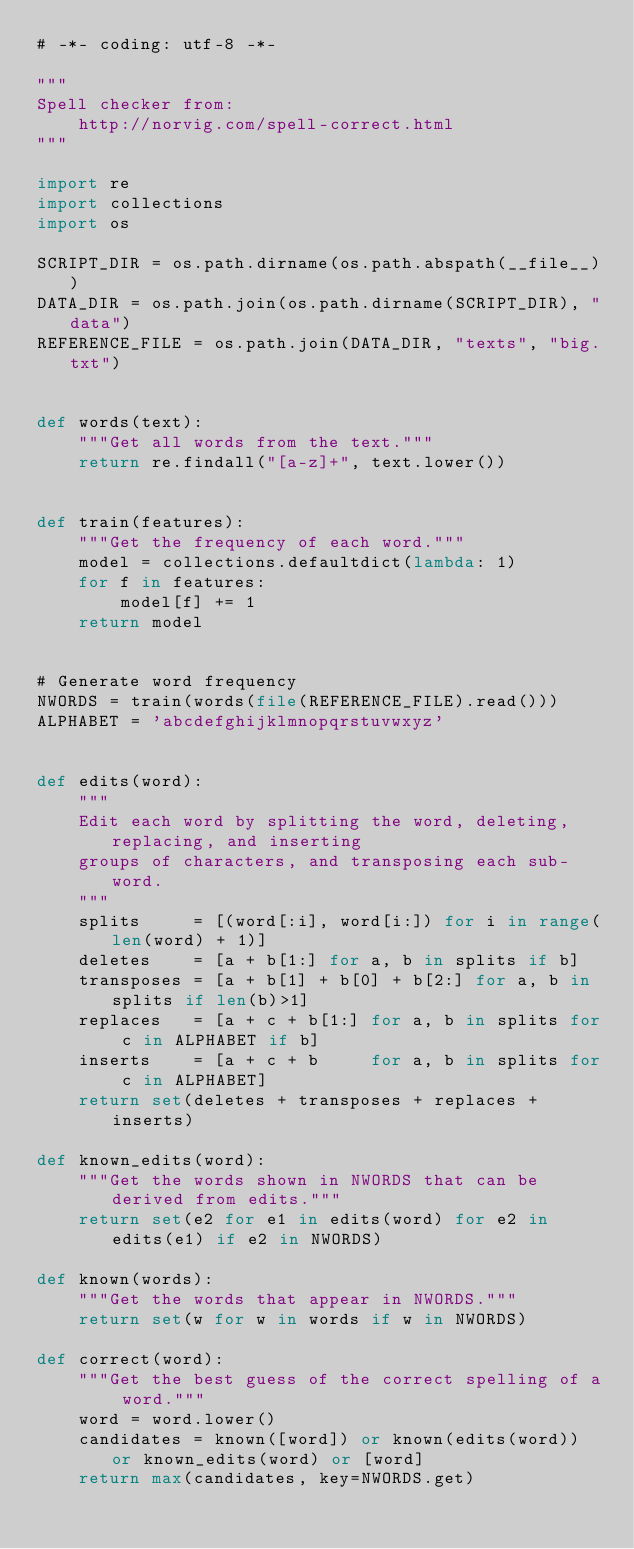<code> <loc_0><loc_0><loc_500><loc_500><_Python_># -*- coding: utf-8 -*-

"""
Spell checker from:
    http://norvig.com/spell-correct.html
"""

import re
import collections
import os

SCRIPT_DIR = os.path.dirname(os.path.abspath(__file__))
DATA_DIR = os.path.join(os.path.dirname(SCRIPT_DIR), "data")
REFERENCE_FILE = os.path.join(DATA_DIR, "texts", "big.txt")


def words(text):
    """Get all words from the text."""
    return re.findall("[a-z]+", text.lower())


def train(features):
    """Get the frequency of each word."""
    model = collections.defaultdict(lambda: 1)
    for f in features:
        model[f] += 1
    return model


# Generate word frequency
NWORDS = train(words(file(REFERENCE_FILE).read()))
ALPHABET = 'abcdefghijklmnopqrstuvwxyz'


def edits(word):
    """
    Edit each word by splitting the word, deleting, replacing, and inserting
    groups of characters, and transposing each sub-word.
    """
    splits     = [(word[:i], word[i:]) for i in range(len(word) + 1)]
    deletes    = [a + b[1:] for a, b in splits if b]
    transposes = [a + b[1] + b[0] + b[2:] for a, b in splits if len(b)>1]
    replaces   = [a + c + b[1:] for a, b in splits for c in ALPHABET if b]
    inserts    = [a + c + b     for a, b in splits for c in ALPHABET]
    return set(deletes + transposes + replaces + inserts)

def known_edits(word):
    """Get the words shown in NWORDS that can be derived from edits."""
    return set(e2 for e1 in edits(word) for e2 in edits(e1) if e2 in NWORDS)

def known(words):
    """Get the words that appear in NWORDS."""
    return set(w for w in words if w in NWORDS)

def correct(word):
    """Get the best guess of the correct spelling of a word."""
    word = word.lower()
    candidates = known([word]) or known(edits(word)) or known_edits(word) or [word]
    return max(candidates, key=NWORDS.get)

</code> 